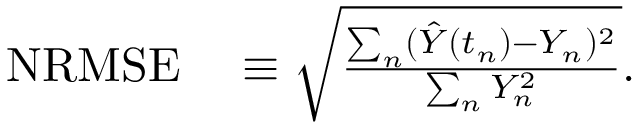<formula> <loc_0><loc_0><loc_500><loc_500>\begin{array} { r l } { N R M S E } & \equiv \sqrt { \frac { \sum _ { n } ( \hat { Y } ( t _ { n } ) - Y _ { n } ) ^ { 2 } } { \sum _ { n } Y _ { n } ^ { 2 } } } . } \end{array}</formula> 